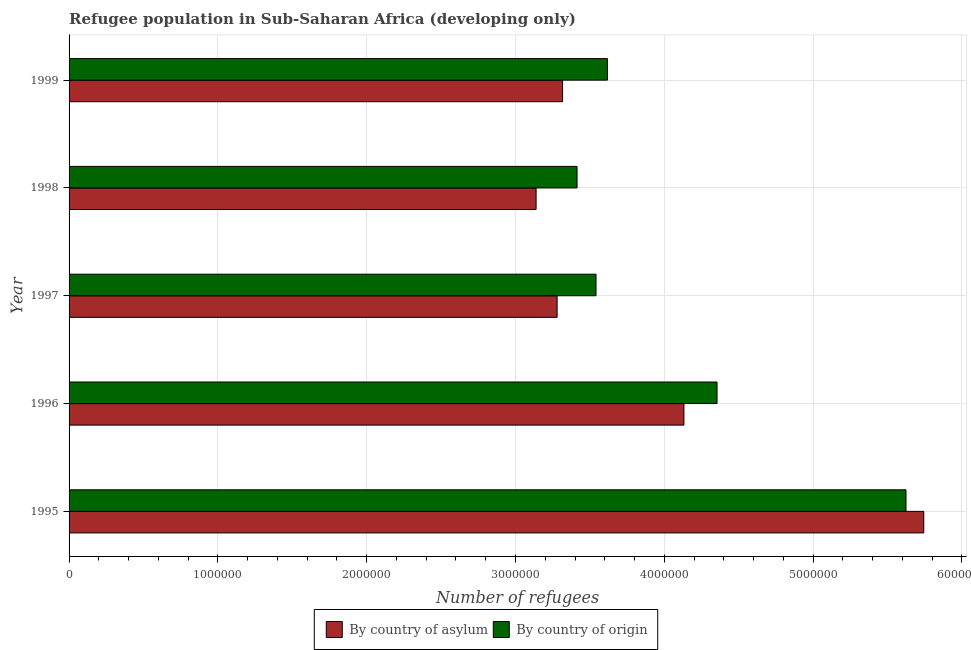How many different coloured bars are there?
Give a very brief answer. 2. How many groups of bars are there?
Offer a very short reply. 5. Are the number of bars on each tick of the Y-axis equal?
Your answer should be very brief. Yes. How many bars are there on the 3rd tick from the top?
Offer a very short reply. 2. What is the number of refugees by country of origin in 1997?
Provide a short and direct response. 3.54e+06. Across all years, what is the maximum number of refugees by country of origin?
Keep it short and to the point. 5.62e+06. Across all years, what is the minimum number of refugees by country of asylum?
Provide a succinct answer. 3.14e+06. In which year was the number of refugees by country of asylum maximum?
Offer a terse response. 1995. What is the total number of refugees by country of asylum in the graph?
Offer a terse response. 1.96e+07. What is the difference between the number of refugees by country of origin in 1997 and that in 1999?
Make the answer very short. -7.68e+04. What is the difference between the number of refugees by country of asylum in 1999 and the number of refugees by country of origin in 1997?
Provide a succinct answer. -2.25e+05. What is the average number of refugees by country of asylum per year?
Offer a terse response. 3.92e+06. In the year 1999, what is the difference between the number of refugees by country of origin and number of refugees by country of asylum?
Ensure brevity in your answer.  3.01e+05. In how many years, is the number of refugees by country of asylum greater than 5200000 ?
Make the answer very short. 1. What is the ratio of the number of refugees by country of asylum in 1995 to that in 1999?
Ensure brevity in your answer.  1.73. Is the number of refugees by country of asylum in 1995 less than that in 1998?
Your answer should be very brief. No. What is the difference between the highest and the second highest number of refugees by country of asylum?
Make the answer very short. 1.61e+06. What is the difference between the highest and the lowest number of refugees by country of asylum?
Offer a very short reply. 2.61e+06. In how many years, is the number of refugees by country of origin greater than the average number of refugees by country of origin taken over all years?
Make the answer very short. 2. What does the 2nd bar from the top in 1998 represents?
Your response must be concise. By country of asylum. What does the 2nd bar from the bottom in 1999 represents?
Offer a very short reply. By country of origin. How many bars are there?
Provide a short and direct response. 10. Are the values on the major ticks of X-axis written in scientific E-notation?
Make the answer very short. No. Does the graph contain any zero values?
Your answer should be compact. No. Where does the legend appear in the graph?
Provide a short and direct response. Bottom center. How are the legend labels stacked?
Provide a succinct answer. Horizontal. What is the title of the graph?
Offer a very short reply. Refugee population in Sub-Saharan Africa (developing only). What is the label or title of the X-axis?
Your answer should be compact. Number of refugees. What is the label or title of the Y-axis?
Your answer should be very brief. Year. What is the Number of refugees of By country of asylum in 1995?
Provide a succinct answer. 5.74e+06. What is the Number of refugees of By country of origin in 1995?
Provide a succinct answer. 5.62e+06. What is the Number of refugees of By country of asylum in 1996?
Offer a very short reply. 4.13e+06. What is the Number of refugees of By country of origin in 1996?
Offer a terse response. 4.35e+06. What is the Number of refugees in By country of asylum in 1997?
Keep it short and to the point. 3.28e+06. What is the Number of refugees of By country of origin in 1997?
Your response must be concise. 3.54e+06. What is the Number of refugees in By country of asylum in 1998?
Your response must be concise. 3.14e+06. What is the Number of refugees in By country of origin in 1998?
Your answer should be very brief. 3.41e+06. What is the Number of refugees of By country of asylum in 1999?
Provide a short and direct response. 3.32e+06. What is the Number of refugees of By country of origin in 1999?
Provide a succinct answer. 3.62e+06. Across all years, what is the maximum Number of refugees of By country of asylum?
Your response must be concise. 5.74e+06. Across all years, what is the maximum Number of refugees in By country of origin?
Ensure brevity in your answer.  5.62e+06. Across all years, what is the minimum Number of refugees in By country of asylum?
Keep it short and to the point. 3.14e+06. Across all years, what is the minimum Number of refugees in By country of origin?
Offer a terse response. 3.41e+06. What is the total Number of refugees of By country of asylum in the graph?
Ensure brevity in your answer.  1.96e+07. What is the total Number of refugees in By country of origin in the graph?
Your response must be concise. 2.06e+07. What is the difference between the Number of refugees in By country of asylum in 1995 and that in 1996?
Your answer should be very brief. 1.61e+06. What is the difference between the Number of refugees of By country of origin in 1995 and that in 1996?
Provide a short and direct response. 1.27e+06. What is the difference between the Number of refugees in By country of asylum in 1995 and that in 1997?
Give a very brief answer. 2.46e+06. What is the difference between the Number of refugees of By country of origin in 1995 and that in 1997?
Your response must be concise. 2.08e+06. What is the difference between the Number of refugees in By country of asylum in 1995 and that in 1998?
Offer a terse response. 2.61e+06. What is the difference between the Number of refugees of By country of origin in 1995 and that in 1998?
Offer a very short reply. 2.21e+06. What is the difference between the Number of refugees in By country of asylum in 1995 and that in 1999?
Your answer should be very brief. 2.43e+06. What is the difference between the Number of refugees in By country of origin in 1995 and that in 1999?
Make the answer very short. 2.01e+06. What is the difference between the Number of refugees in By country of asylum in 1996 and that in 1997?
Offer a very short reply. 8.52e+05. What is the difference between the Number of refugees of By country of origin in 1996 and that in 1997?
Give a very brief answer. 8.13e+05. What is the difference between the Number of refugees of By country of asylum in 1996 and that in 1998?
Ensure brevity in your answer.  9.94e+05. What is the difference between the Number of refugees in By country of origin in 1996 and that in 1998?
Make the answer very short. 9.41e+05. What is the difference between the Number of refugees of By country of asylum in 1996 and that in 1999?
Ensure brevity in your answer.  8.15e+05. What is the difference between the Number of refugees of By country of origin in 1996 and that in 1999?
Your answer should be very brief. 7.36e+05. What is the difference between the Number of refugees in By country of asylum in 1997 and that in 1998?
Your answer should be compact. 1.41e+05. What is the difference between the Number of refugees of By country of origin in 1997 and that in 1998?
Keep it short and to the point. 1.27e+05. What is the difference between the Number of refugees in By country of asylum in 1997 and that in 1999?
Your answer should be very brief. -3.68e+04. What is the difference between the Number of refugees of By country of origin in 1997 and that in 1999?
Your answer should be compact. -7.68e+04. What is the difference between the Number of refugees of By country of asylum in 1998 and that in 1999?
Keep it short and to the point. -1.78e+05. What is the difference between the Number of refugees of By country of origin in 1998 and that in 1999?
Your answer should be very brief. -2.04e+05. What is the difference between the Number of refugees in By country of asylum in 1995 and the Number of refugees in By country of origin in 1996?
Provide a short and direct response. 1.39e+06. What is the difference between the Number of refugees in By country of asylum in 1995 and the Number of refugees in By country of origin in 1997?
Provide a short and direct response. 2.20e+06. What is the difference between the Number of refugees of By country of asylum in 1995 and the Number of refugees of By country of origin in 1998?
Provide a short and direct response. 2.33e+06. What is the difference between the Number of refugees of By country of asylum in 1995 and the Number of refugees of By country of origin in 1999?
Offer a terse response. 2.13e+06. What is the difference between the Number of refugees in By country of asylum in 1996 and the Number of refugees in By country of origin in 1997?
Provide a short and direct response. 5.91e+05. What is the difference between the Number of refugees of By country of asylum in 1996 and the Number of refugees of By country of origin in 1998?
Ensure brevity in your answer.  7.18e+05. What is the difference between the Number of refugees of By country of asylum in 1996 and the Number of refugees of By country of origin in 1999?
Your response must be concise. 5.14e+05. What is the difference between the Number of refugees in By country of asylum in 1997 and the Number of refugees in By country of origin in 1998?
Your answer should be very brief. -1.34e+05. What is the difference between the Number of refugees of By country of asylum in 1997 and the Number of refugees of By country of origin in 1999?
Keep it short and to the point. -3.38e+05. What is the difference between the Number of refugees in By country of asylum in 1998 and the Number of refugees in By country of origin in 1999?
Provide a succinct answer. -4.80e+05. What is the average Number of refugees of By country of asylum per year?
Give a very brief answer. 3.92e+06. What is the average Number of refugees of By country of origin per year?
Your response must be concise. 4.11e+06. In the year 1995, what is the difference between the Number of refugees of By country of asylum and Number of refugees of By country of origin?
Offer a very short reply. 1.19e+05. In the year 1996, what is the difference between the Number of refugees in By country of asylum and Number of refugees in By country of origin?
Give a very brief answer. -2.22e+05. In the year 1997, what is the difference between the Number of refugees in By country of asylum and Number of refugees in By country of origin?
Offer a very short reply. -2.61e+05. In the year 1998, what is the difference between the Number of refugees in By country of asylum and Number of refugees in By country of origin?
Ensure brevity in your answer.  -2.75e+05. In the year 1999, what is the difference between the Number of refugees of By country of asylum and Number of refugees of By country of origin?
Your response must be concise. -3.01e+05. What is the ratio of the Number of refugees in By country of asylum in 1995 to that in 1996?
Your answer should be very brief. 1.39. What is the ratio of the Number of refugees in By country of origin in 1995 to that in 1996?
Your response must be concise. 1.29. What is the ratio of the Number of refugees of By country of asylum in 1995 to that in 1997?
Ensure brevity in your answer.  1.75. What is the ratio of the Number of refugees in By country of origin in 1995 to that in 1997?
Your response must be concise. 1.59. What is the ratio of the Number of refugees of By country of asylum in 1995 to that in 1998?
Offer a very short reply. 1.83. What is the ratio of the Number of refugees of By country of origin in 1995 to that in 1998?
Offer a terse response. 1.65. What is the ratio of the Number of refugees of By country of asylum in 1995 to that in 1999?
Your answer should be compact. 1.73. What is the ratio of the Number of refugees in By country of origin in 1995 to that in 1999?
Offer a very short reply. 1.55. What is the ratio of the Number of refugees in By country of asylum in 1996 to that in 1997?
Ensure brevity in your answer.  1.26. What is the ratio of the Number of refugees of By country of origin in 1996 to that in 1997?
Ensure brevity in your answer.  1.23. What is the ratio of the Number of refugees of By country of asylum in 1996 to that in 1998?
Your response must be concise. 1.32. What is the ratio of the Number of refugees of By country of origin in 1996 to that in 1998?
Keep it short and to the point. 1.28. What is the ratio of the Number of refugees of By country of asylum in 1996 to that in 1999?
Offer a very short reply. 1.25. What is the ratio of the Number of refugees in By country of origin in 1996 to that in 1999?
Give a very brief answer. 1.2. What is the ratio of the Number of refugees in By country of asylum in 1997 to that in 1998?
Make the answer very short. 1.04. What is the ratio of the Number of refugees of By country of origin in 1997 to that in 1998?
Ensure brevity in your answer.  1.04. What is the ratio of the Number of refugees of By country of asylum in 1997 to that in 1999?
Offer a very short reply. 0.99. What is the ratio of the Number of refugees of By country of origin in 1997 to that in 1999?
Offer a very short reply. 0.98. What is the ratio of the Number of refugees in By country of asylum in 1998 to that in 1999?
Keep it short and to the point. 0.95. What is the ratio of the Number of refugees in By country of origin in 1998 to that in 1999?
Your response must be concise. 0.94. What is the difference between the highest and the second highest Number of refugees in By country of asylum?
Provide a succinct answer. 1.61e+06. What is the difference between the highest and the second highest Number of refugees in By country of origin?
Make the answer very short. 1.27e+06. What is the difference between the highest and the lowest Number of refugees in By country of asylum?
Offer a very short reply. 2.61e+06. What is the difference between the highest and the lowest Number of refugees in By country of origin?
Offer a terse response. 2.21e+06. 